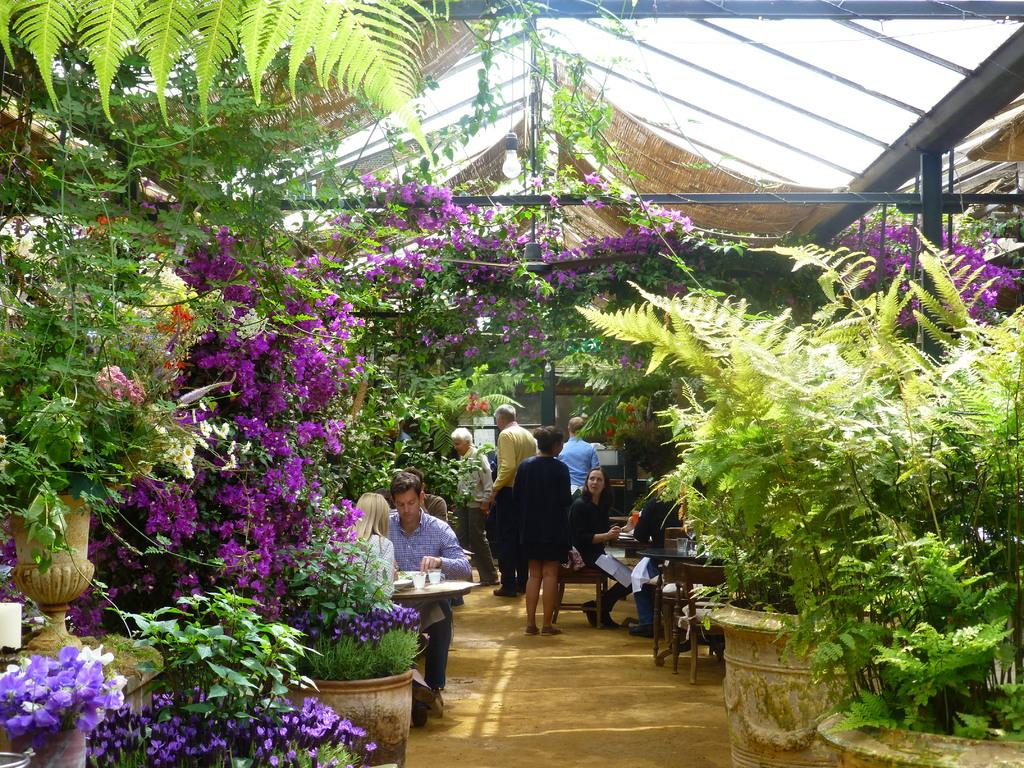What type of establishment is depicted in the image? The image appears to depict a restaurant. What are the people in the image doing? Some people are sitting, while others are standing in the restaurant. Are there any decorative elements in the restaurant? Yes, there are beautiful plants around the restaurant. Is there a spy sitting at the table in the image? There is no indication in the image that any of the people in the restaurant are spies. What type of silverware is visible on the tables in the image? The image does not show any silverware on the tables, so it cannot be determined from the picture. 